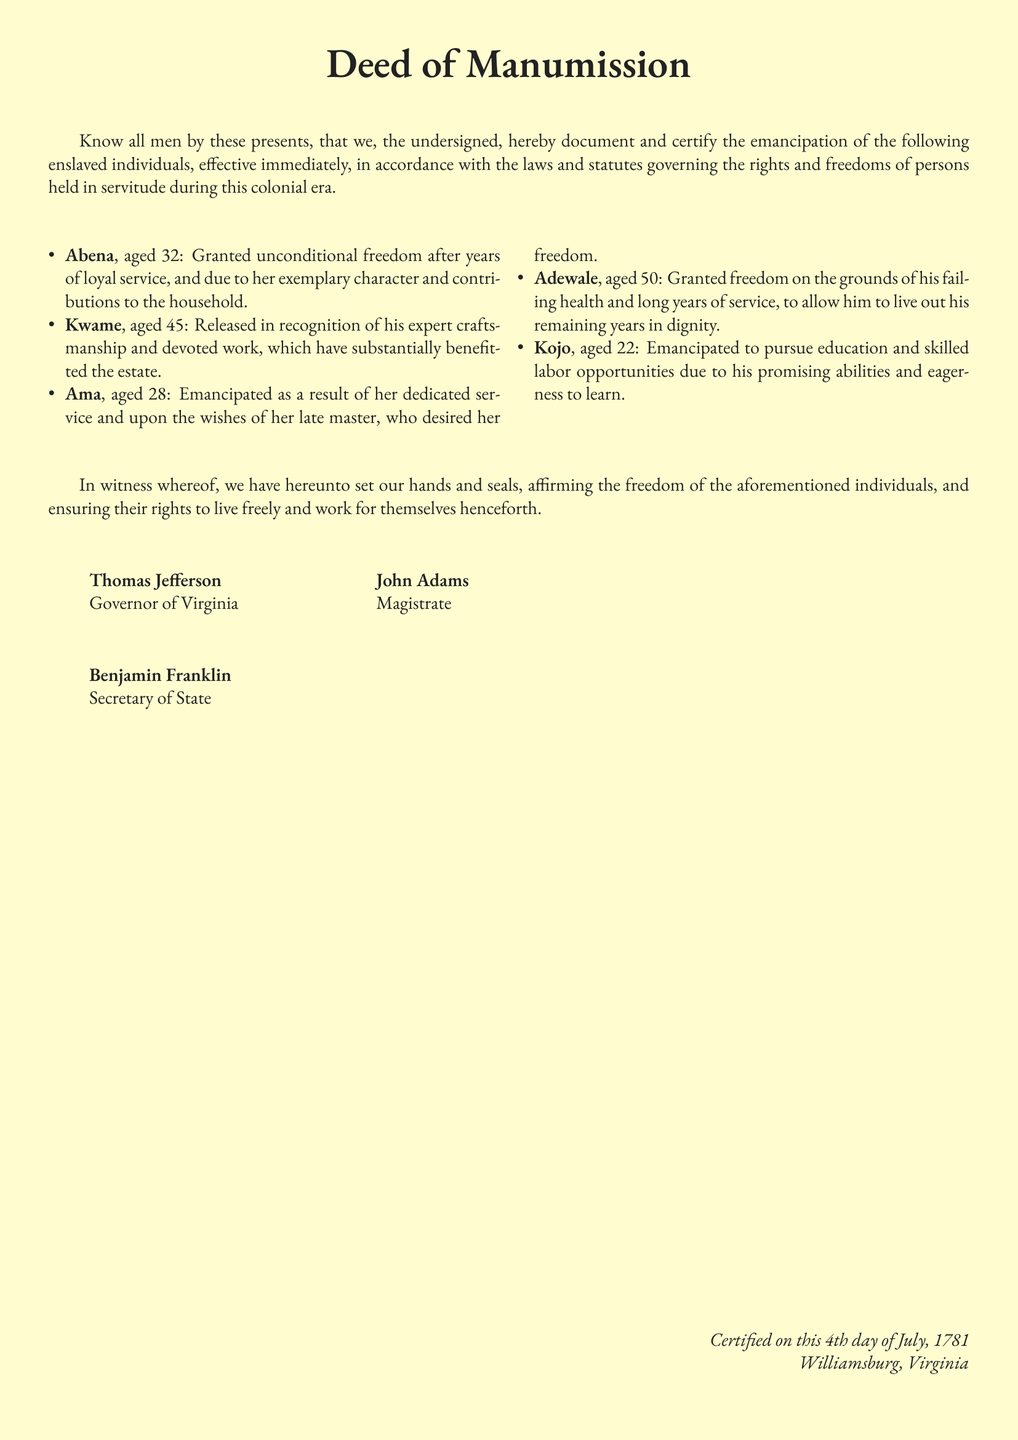What is the title of the document? The title is prominently displayed at the top of the document, indicating its nature and purpose.
Answer: Deed of Manumission How many individuals are emancipated in the document? The number of individuals is listed in the bullet points section, detailing each person's name and age.
Answer: Five What is the age of Abena? Abena's age is provided along with her name in the list of emancipated individuals.
Answer: 32 Who granted freedom to the enslaved individuals? The individuals responsible for the emancipation are listed at the bottom of the document as signatories.
Answer: Thomas Jefferson What was the reason for Adewale's emancipation? Adewale's specific circumstances leading to his freedom are described in the bullet points, providing context.
Answer: Failing health What date was the deed certified? The certification date is mentioned in the conclusion section of the document.
Answer: 4th day of July, 1781 What is the name of the magistrate listed in the document? The magistrate's name is included among the signatories at the bottom of the document.
Answer: John Adams Which individual was emancipated to pursue education? The document specifies the aspirations of the individual in question, highlighting their potential.
Answer: Kojo 